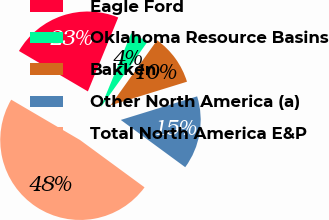<chart> <loc_0><loc_0><loc_500><loc_500><pie_chart><fcel>Eagle Ford<fcel>Oklahoma Resource Basins<fcel>Bakken<fcel>Other North America (a)<fcel>Total North America E&P<nl><fcel>22.76%<fcel>3.66%<fcel>10.37%<fcel>14.84%<fcel>48.37%<nl></chart> 